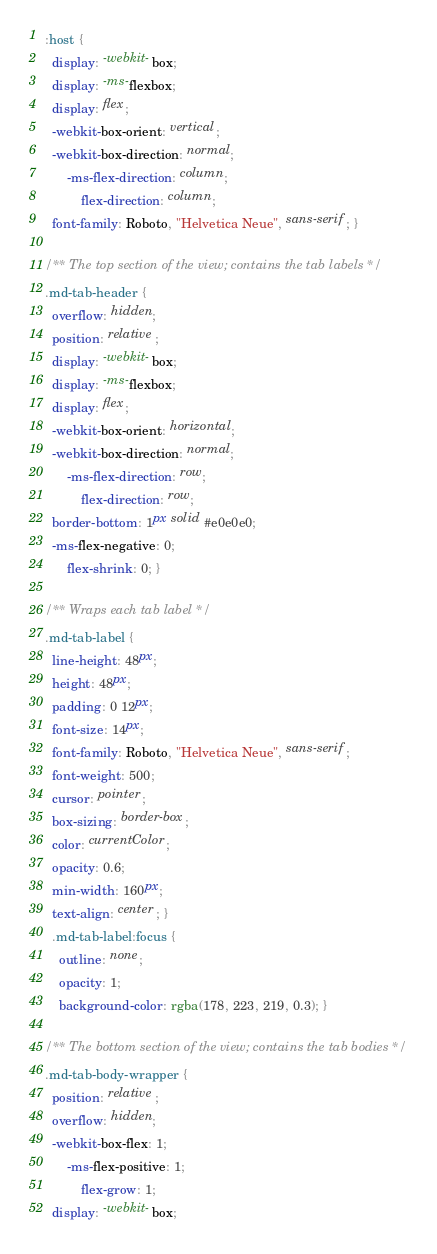Convert code to text. <code><loc_0><loc_0><loc_500><loc_500><_CSS_>:host {
  display: -webkit-box;
  display: -ms-flexbox;
  display: flex;
  -webkit-box-orient: vertical;
  -webkit-box-direction: normal;
      -ms-flex-direction: column;
          flex-direction: column;
  font-family: Roboto, "Helvetica Neue", sans-serif; }

/** The top section of the view; contains the tab labels */
.md-tab-header {
  overflow: hidden;
  position: relative;
  display: -webkit-box;
  display: -ms-flexbox;
  display: flex;
  -webkit-box-orient: horizontal;
  -webkit-box-direction: normal;
      -ms-flex-direction: row;
          flex-direction: row;
  border-bottom: 1px solid #e0e0e0;
  -ms-flex-negative: 0;
      flex-shrink: 0; }

/** Wraps each tab label */
.md-tab-label {
  line-height: 48px;
  height: 48px;
  padding: 0 12px;
  font-size: 14px;
  font-family: Roboto, "Helvetica Neue", sans-serif;
  font-weight: 500;
  cursor: pointer;
  box-sizing: border-box;
  color: currentColor;
  opacity: 0.6;
  min-width: 160px;
  text-align: center; }
  .md-tab-label:focus {
    outline: none;
    opacity: 1;
    background-color: rgba(178, 223, 219, 0.3); }

/** The bottom section of the view; contains the tab bodies */
.md-tab-body-wrapper {
  position: relative;
  overflow: hidden;
  -webkit-box-flex: 1;
      -ms-flex-positive: 1;
          flex-grow: 1;
  display: -webkit-box;</code> 